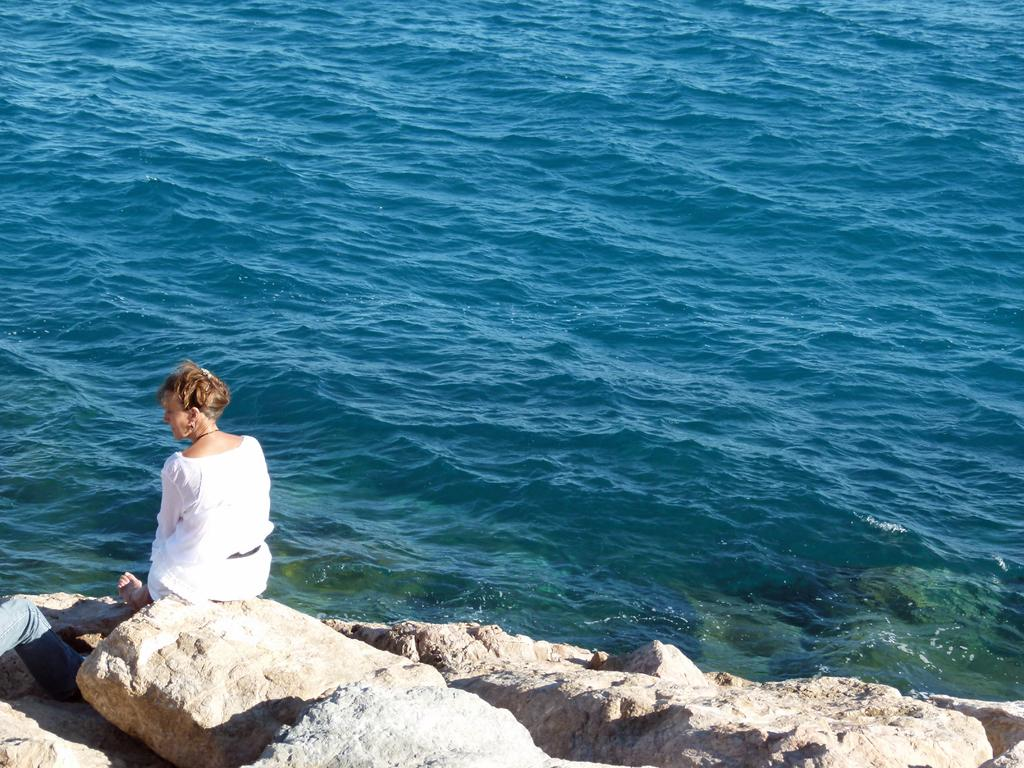What is the lady in the foreground of the image doing? The lady is sitting on stones in the foreground of the image. Can you describe anything else visible on the left side of the image? There are person's legs visible to the left side of the image. What can be seen in the background of the image? There is water in the background of the image. What type of paper is the lady holding in the image? There is no paper visible in the image; the lady is sitting on stones and there are no other objects mentioned. 